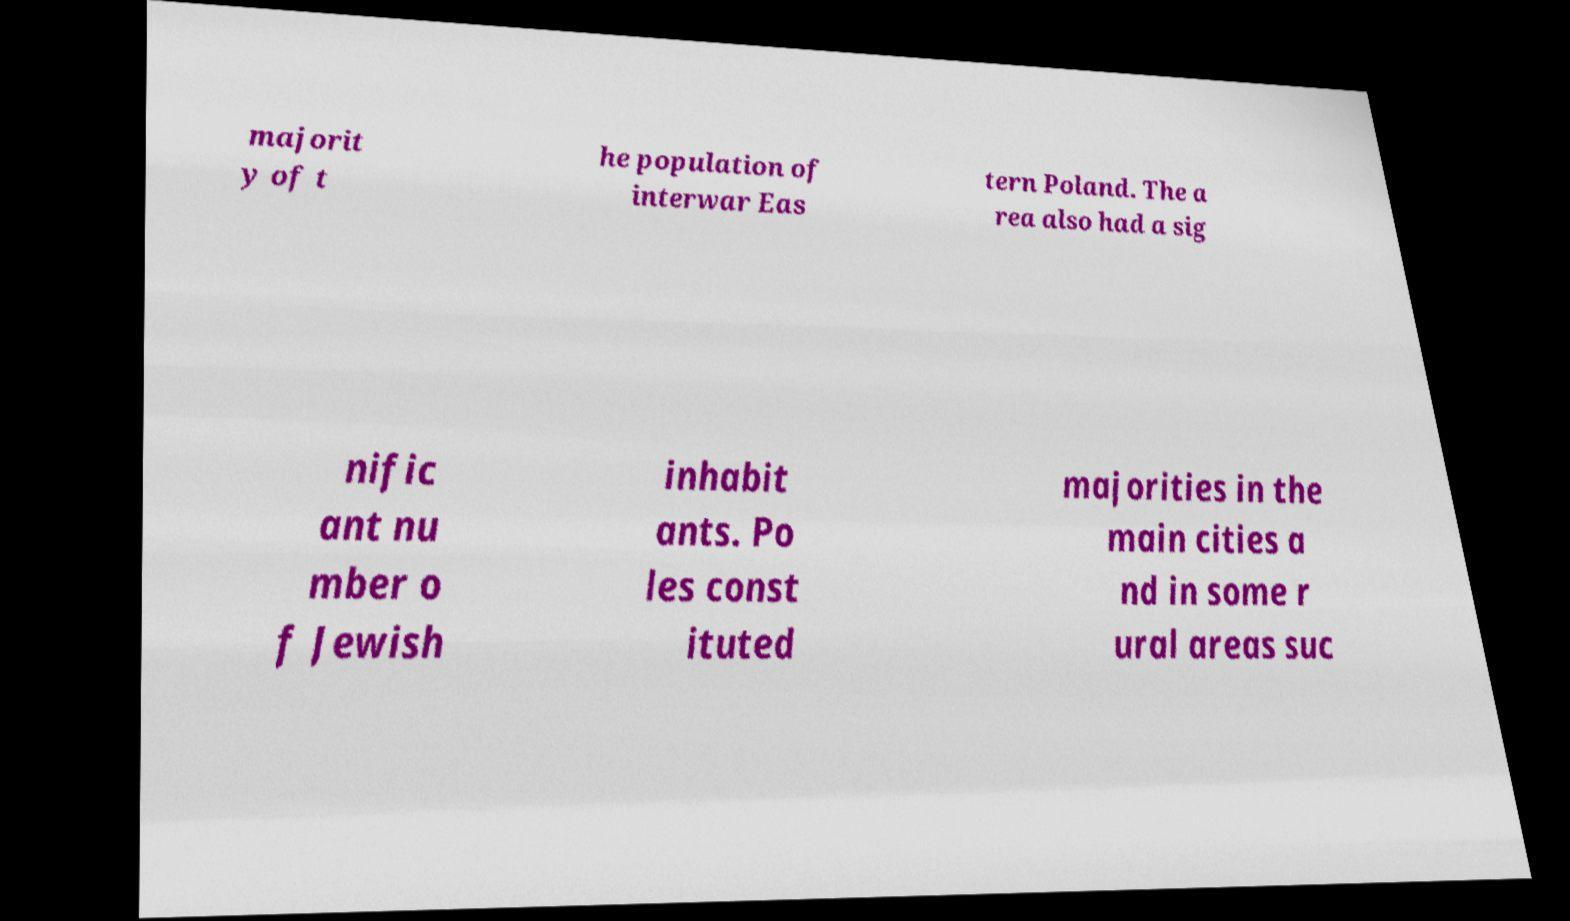Can you accurately transcribe the text from the provided image for me? majorit y of t he population of interwar Eas tern Poland. The a rea also had a sig nific ant nu mber o f Jewish inhabit ants. Po les const ituted majorities in the main cities a nd in some r ural areas suc 